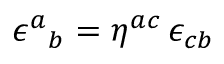Convert formula to latex. <formula><loc_0><loc_0><loc_500><loc_500>\epsilon ^ { a _ { b } = \eta ^ { a c } \, \epsilon _ { c b }</formula> 